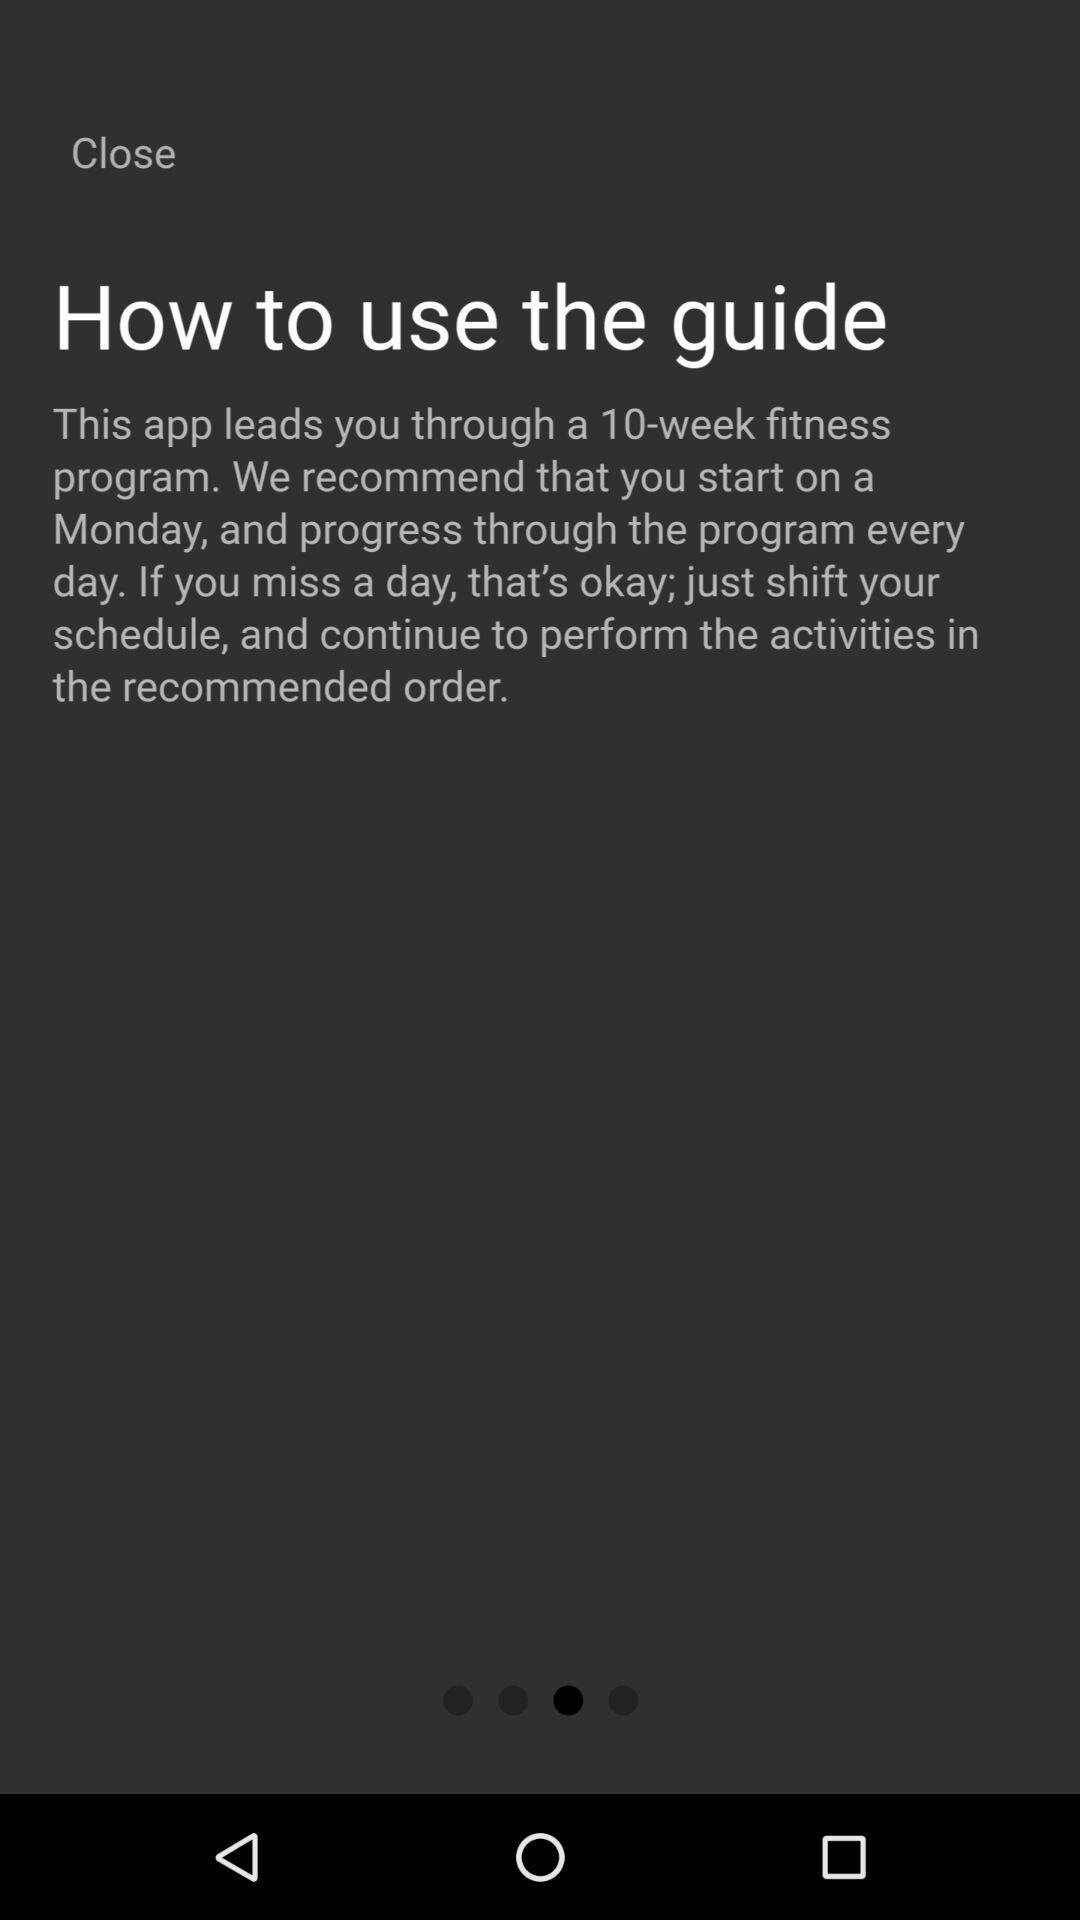On which day of the week will the fitness program end?
When the provided information is insufficient, respond with <no answer>. <no answer> 